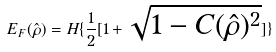Convert formula to latex. <formula><loc_0><loc_0><loc_500><loc_500>E _ { F } ( \hat { \rho } ) = H \{ \frac { 1 } { 2 } [ 1 + \sqrt { 1 - C ( \hat { \rho } ) ^ { 2 } } ] \}</formula> 